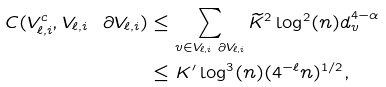<formula> <loc_0><loc_0><loc_500><loc_500>C ( V _ { \ell , i } ^ { c } , V _ { \ell , i } \ \partial V _ { \ell , i } ) & \leq \sum _ { v \in V _ { \ell , i } \ \partial V _ { \ell , i } } \widetilde { K } ^ { 2 } \log ^ { 2 } ( n ) d _ { v } ^ { 4 - \alpha } \\ & \leq K ^ { \prime } \log ^ { 3 } ( n ) ( 4 ^ { - \ell } n ) ^ { 1 / 2 } ,</formula> 